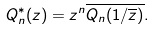Convert formula to latex. <formula><loc_0><loc_0><loc_500><loc_500>Q _ { n } ^ { * } ( z ) = z ^ { n } \overline { Q _ { n } ( 1 / \overline { z } ) } .</formula> 